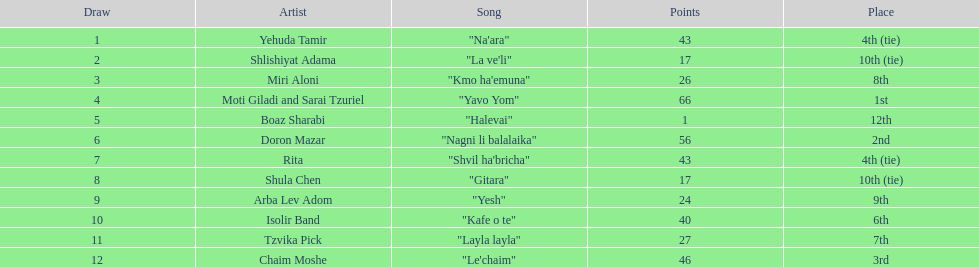What is the name of the first song listed on this chart? "Na'ara". 